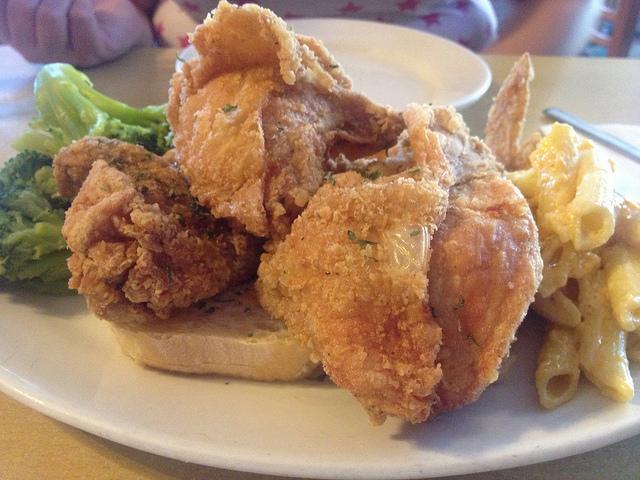How many bowls are there?
Give a very brief answer. 2. How many dogs are here?
Give a very brief answer. 0. 